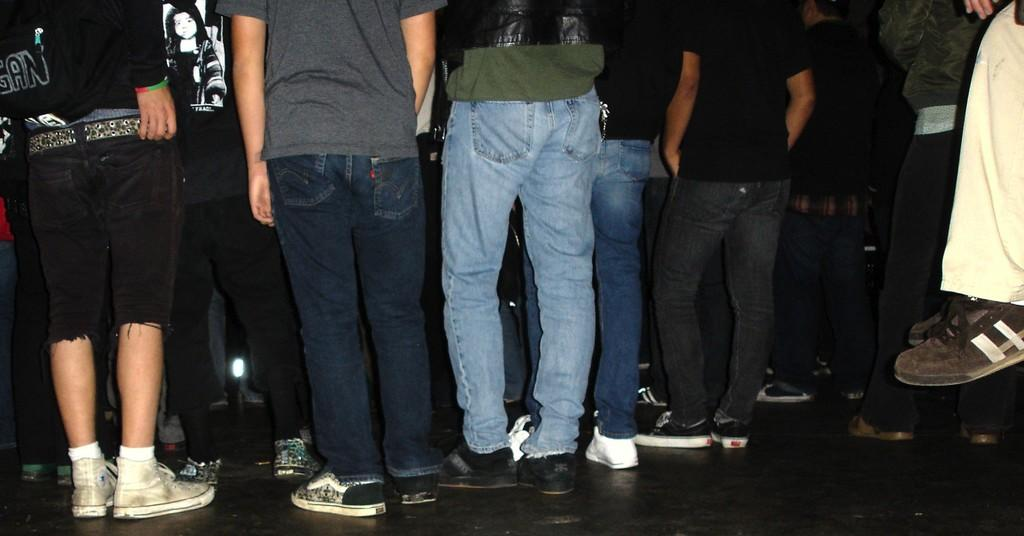What can be seen in the image? There are people standing in the image. Where are the people standing? The people are standing on the floor. What are the people wearing on their feet? The people are wearing different types of shoes. What type of furniture can be seen in the image? There is no furniture visible in the image; it only shows people standing on the floor. 